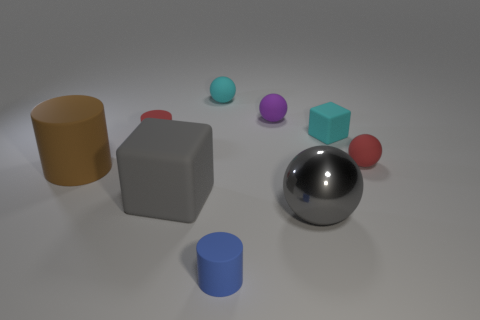How many other objects are the same color as the big shiny object?
Your answer should be compact. 1. What color is the cylinder that is behind the large gray cube and in front of the red rubber cylinder?
Offer a very short reply. Brown. What number of objects are either small blue things or big rubber objects left of the big gray block?
Ensure brevity in your answer.  2. What is the material of the ball that is in front of the big brown rubber object that is to the left of the metallic object that is in front of the large rubber cylinder?
Keep it short and to the point. Metal. Is there anything else that has the same material as the large gray ball?
Offer a terse response. No. Do the block that is left of the big metal sphere and the metallic ball have the same color?
Give a very brief answer. Yes. What number of red things are either blocks or small matte cylinders?
Provide a succinct answer. 1. How many other objects are the same shape as the big shiny thing?
Your response must be concise. 3. Is the material of the big cube the same as the cyan sphere?
Offer a terse response. Yes. There is a thing that is both to the left of the blue thing and in front of the big rubber cylinder; what material is it?
Keep it short and to the point. Rubber. 